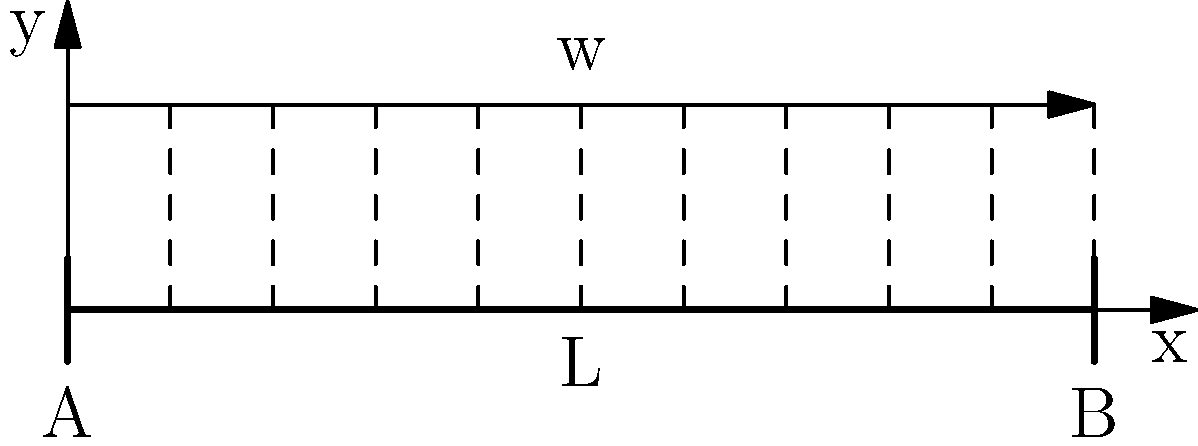A simply supported beam of length L is subjected to a uniformly distributed load w along its entire length, as shown in the figure. Calculate the maximum bending moment in the beam and determine its location. Express your answer in terms of w and L. To solve this problem, let's follow these steps:

1) First, we need to determine the reactions at the supports. Due to symmetry, the reactions at both supports A and B will be equal:

   $R_A = R_B = \frac{wL}{2}$

2) Now, let's consider a section at distance x from the left support. The bending moment M at this section is:

   $M = R_A \cdot x - w \cdot x \cdot \frac{x}{2}$

3) Substituting the value of $R_A$:

   $M = \frac{wL}{2} \cdot x - \frac{wx^2}{2}$

4) To find the maximum bending moment, we need to differentiate M with respect to x and set it to zero:

   $\frac{dM}{dx} = \frac{wL}{2} - wx = 0$

5) Solving this equation:

   $x = \frac{L}{2}$

6) This confirms that the maximum bending moment occurs at the middle of the beam.

7) To find the maximum bending moment, we substitute $x = \frac{L}{2}$ into the expression for M:

   $M_{max} = \frac{wL}{2} \cdot \frac{L}{2} - \frac{w(\frac{L}{2})^2}{2}$

8) Simplifying:

   $M_{max} = \frac{wL^2}{8}$

Therefore, the maximum bending moment is $\frac{wL^2}{8}$ and it occurs at the middle of the beam.
Answer: $M_{max} = \frac{wL^2}{8}$ at $x = \frac{L}{2}$ 